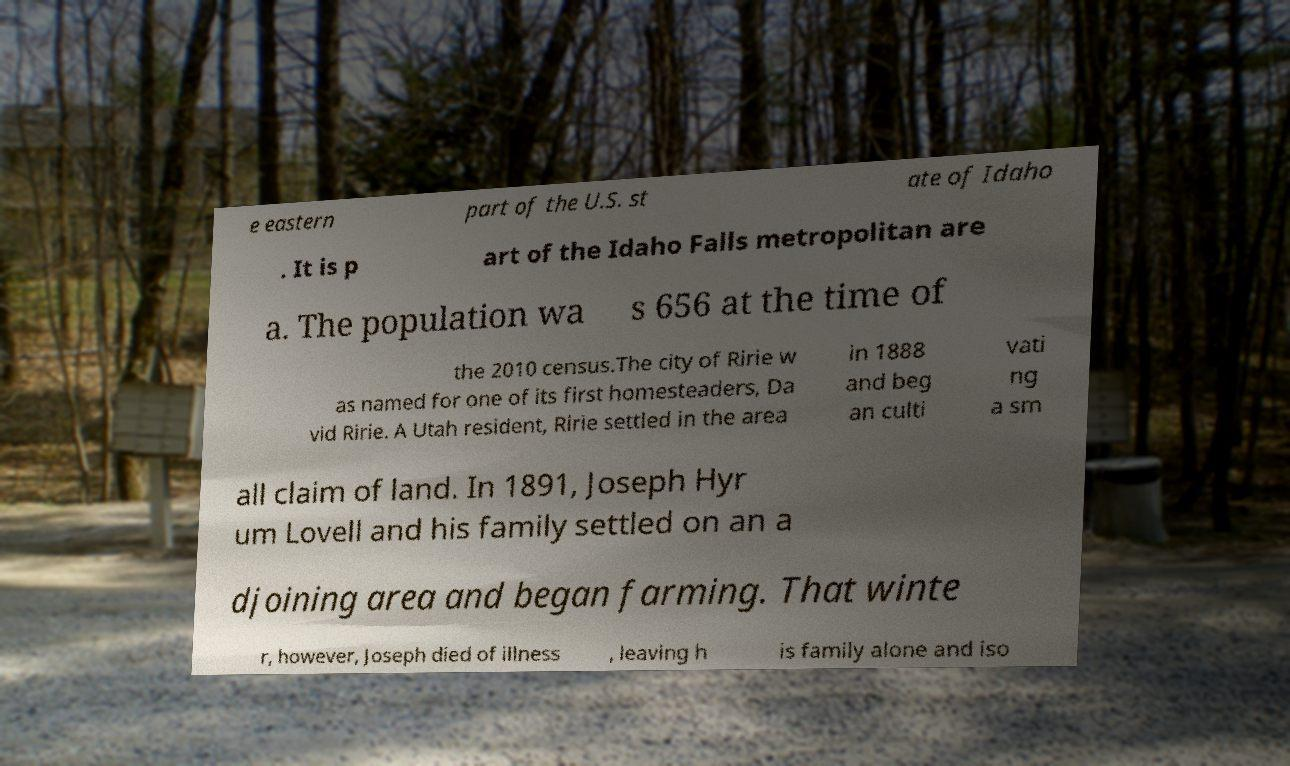I need the written content from this picture converted into text. Can you do that? e eastern part of the U.S. st ate of Idaho . It is p art of the Idaho Falls metropolitan are a. The population wa s 656 at the time of the 2010 census.The city of Ririe w as named for one of its first homesteaders, Da vid Ririe. A Utah resident, Ririe settled in the area in 1888 and beg an culti vati ng a sm all claim of land. In 1891, Joseph Hyr um Lovell and his family settled on an a djoining area and began farming. That winte r, however, Joseph died of illness , leaving h is family alone and iso 